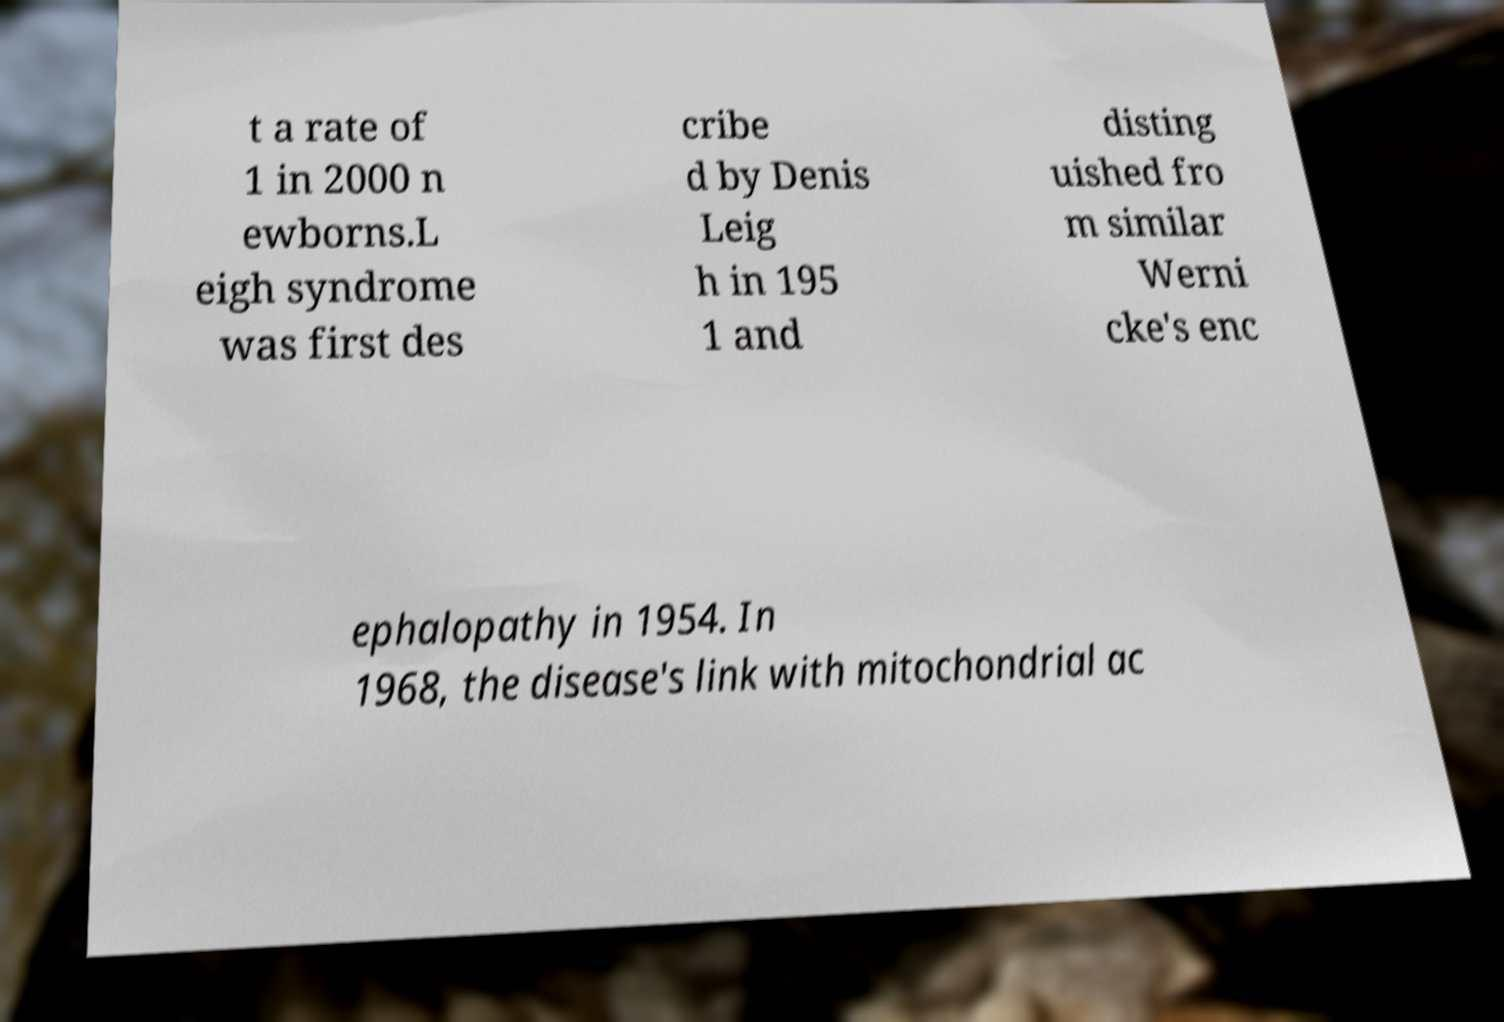Please identify and transcribe the text found in this image. t a rate of 1 in 2000 n ewborns.L eigh syndrome was first des cribe d by Denis Leig h in 195 1 and disting uished fro m similar Werni cke's enc ephalopathy in 1954. In 1968, the disease's link with mitochondrial ac 